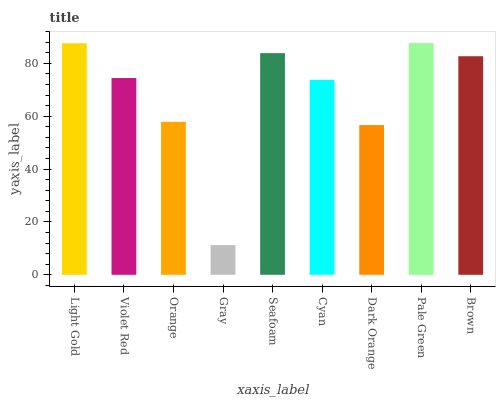Is Gray the minimum?
Answer yes or no. Yes. Is Pale Green the maximum?
Answer yes or no. Yes. Is Violet Red the minimum?
Answer yes or no. No. Is Violet Red the maximum?
Answer yes or no. No. Is Light Gold greater than Violet Red?
Answer yes or no. Yes. Is Violet Red less than Light Gold?
Answer yes or no. Yes. Is Violet Red greater than Light Gold?
Answer yes or no. No. Is Light Gold less than Violet Red?
Answer yes or no. No. Is Violet Red the high median?
Answer yes or no. Yes. Is Violet Red the low median?
Answer yes or no. Yes. Is Seafoam the high median?
Answer yes or no. No. Is Orange the low median?
Answer yes or no. No. 